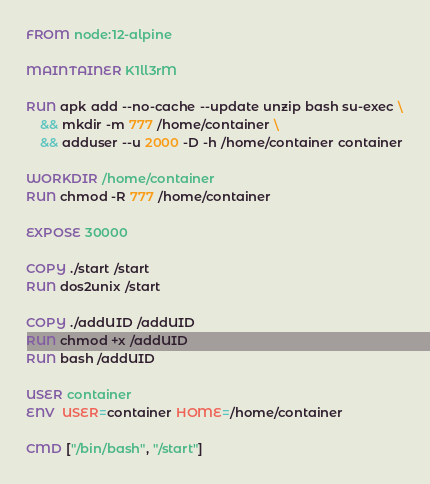Convert code to text. <code><loc_0><loc_0><loc_500><loc_500><_Dockerfile_>FROM node:12-alpine

MAINTAINER K1ll3rM

RUN apk add --no-cache --update unzip bash su-exec \
    && mkdir -m 777 /home/container \
    && adduser --u 2000 -D -h /home/container container

WORKDIR /home/container
RUN chmod -R 777 /home/container

EXPOSE 30000

COPY ./start /start
RUN dos2unix /start

COPY ./addUID /addUID
RUN chmod +x /addUID
RUN bash /addUID

USER container
ENV  USER=container HOME=/home/container

CMD ["/bin/bash", "/start"]</code> 